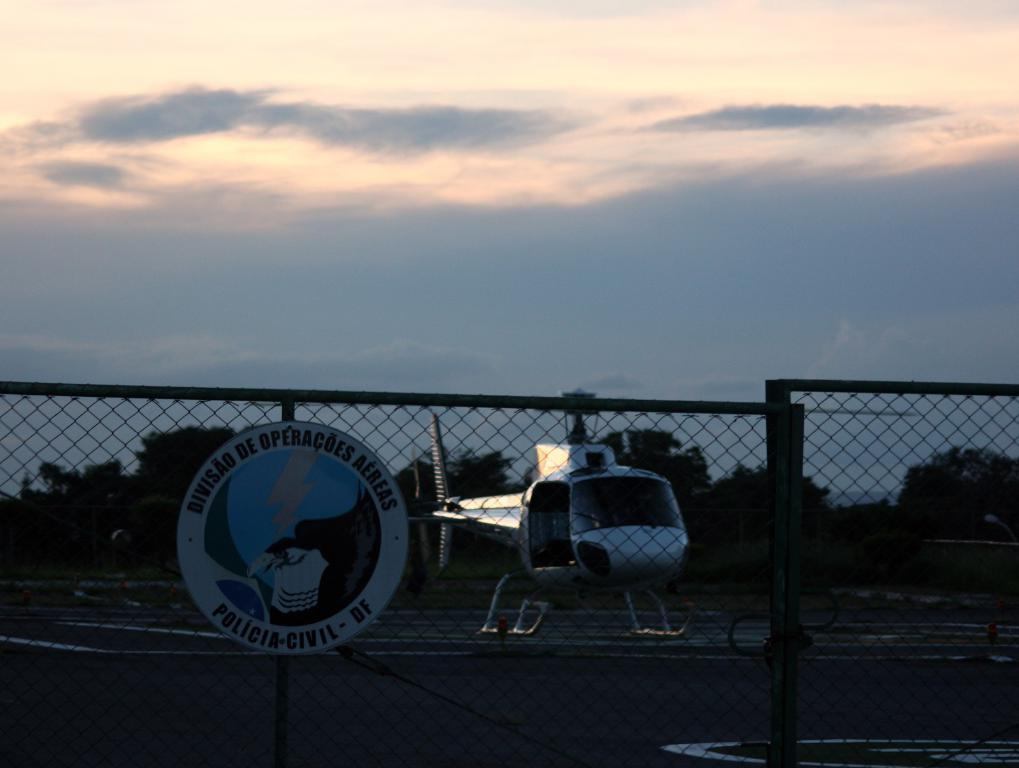What type of structure can be seen in the image? There is a fencing in the image. What is happening behind the fencing? A helicopter is landing on a helipad. What can be seen around the helipad? There are trees around the helipad. What is visible in the background of the image? The sky is visible in the background of the image. What is the opinion of the trees about the helicopter landing? Trees do not have opinions, as they are inanimate objects. 